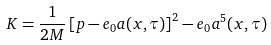Convert formula to latex. <formula><loc_0><loc_0><loc_500><loc_500>K = \frac { 1 } { 2 M } \left [ p - e _ { 0 } a ( x , \tau ) \right ] ^ { 2 } - e _ { 0 } a ^ { 5 } ( x , \tau )</formula> 